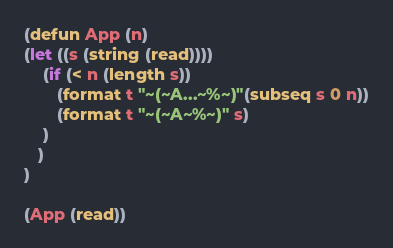Convert code to text. <code><loc_0><loc_0><loc_500><loc_500><_Lisp_>(defun App (n)
(let ((s (string (read))))
    (if (< n (length s))
       (format t "~(~A...~%~)"(subseq s 0 n))
       (format t "~(~A~%~)" s)
    )
   )
)

(App (read))</code> 